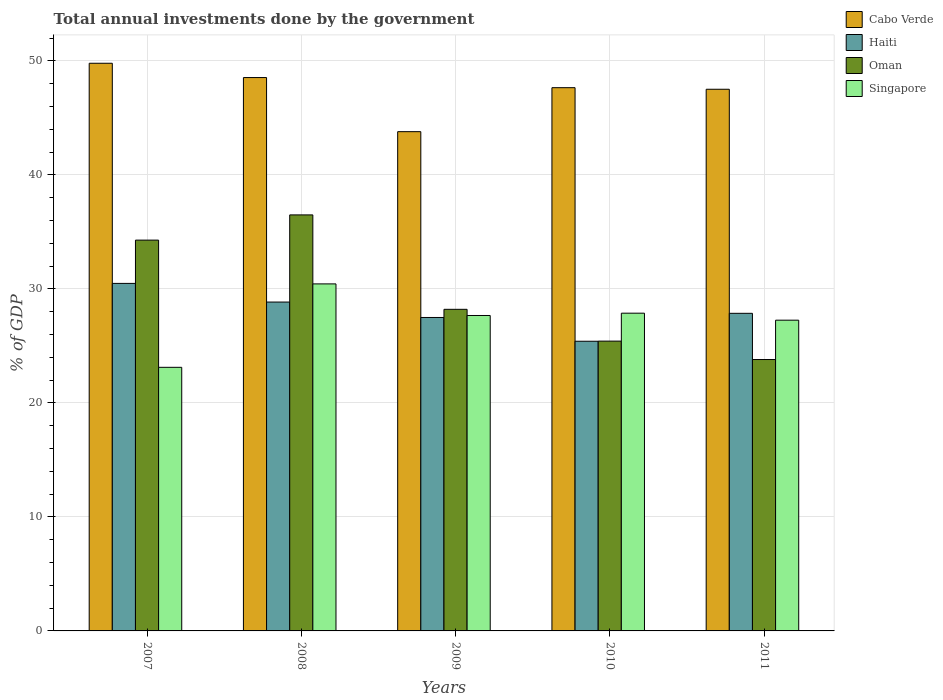How many different coloured bars are there?
Keep it short and to the point. 4. How many groups of bars are there?
Provide a succinct answer. 5. Are the number of bars per tick equal to the number of legend labels?
Keep it short and to the point. Yes. How many bars are there on the 4th tick from the left?
Keep it short and to the point. 4. How many bars are there on the 4th tick from the right?
Offer a terse response. 4. What is the label of the 2nd group of bars from the left?
Your answer should be compact. 2008. What is the total annual investments done by the government in Cabo Verde in 2010?
Your answer should be compact. 47.65. Across all years, what is the maximum total annual investments done by the government in Singapore?
Keep it short and to the point. 30.44. Across all years, what is the minimum total annual investments done by the government in Cabo Verde?
Your response must be concise. 43.79. What is the total total annual investments done by the government in Singapore in the graph?
Keep it short and to the point. 136.35. What is the difference between the total annual investments done by the government in Oman in 2010 and that in 2011?
Offer a terse response. 1.61. What is the difference between the total annual investments done by the government in Singapore in 2011 and the total annual investments done by the government in Cabo Verde in 2009?
Your answer should be compact. -16.53. What is the average total annual investments done by the government in Singapore per year?
Provide a succinct answer. 27.27. In the year 2009, what is the difference between the total annual investments done by the government in Singapore and total annual investments done by the government in Cabo Verde?
Make the answer very short. -16.12. In how many years, is the total annual investments done by the government in Haiti greater than 26 %?
Offer a very short reply. 4. What is the ratio of the total annual investments done by the government in Singapore in 2007 to that in 2008?
Give a very brief answer. 0.76. Is the total annual investments done by the government in Haiti in 2007 less than that in 2009?
Your response must be concise. No. What is the difference between the highest and the second highest total annual investments done by the government in Singapore?
Your answer should be very brief. 2.57. What is the difference between the highest and the lowest total annual investments done by the government in Cabo Verde?
Offer a terse response. 6. Is the sum of the total annual investments done by the government in Haiti in 2008 and 2010 greater than the maximum total annual investments done by the government in Cabo Verde across all years?
Offer a terse response. Yes. Is it the case that in every year, the sum of the total annual investments done by the government in Singapore and total annual investments done by the government in Oman is greater than the sum of total annual investments done by the government in Haiti and total annual investments done by the government in Cabo Verde?
Ensure brevity in your answer.  No. What does the 2nd bar from the left in 2011 represents?
Offer a very short reply. Haiti. What does the 2nd bar from the right in 2008 represents?
Provide a succinct answer. Oman. Is it the case that in every year, the sum of the total annual investments done by the government in Oman and total annual investments done by the government in Singapore is greater than the total annual investments done by the government in Cabo Verde?
Your answer should be very brief. Yes. How many bars are there?
Your answer should be very brief. 20. Are all the bars in the graph horizontal?
Provide a short and direct response. No. How many years are there in the graph?
Provide a short and direct response. 5. Does the graph contain any zero values?
Your answer should be compact. No. Does the graph contain grids?
Make the answer very short. Yes. How many legend labels are there?
Your answer should be very brief. 4. What is the title of the graph?
Offer a very short reply. Total annual investments done by the government. Does "Morocco" appear as one of the legend labels in the graph?
Provide a succinct answer. No. What is the label or title of the Y-axis?
Make the answer very short. % of GDP. What is the % of GDP of Cabo Verde in 2007?
Your response must be concise. 49.79. What is the % of GDP in Haiti in 2007?
Offer a very short reply. 30.48. What is the % of GDP of Oman in 2007?
Keep it short and to the point. 34.28. What is the % of GDP in Singapore in 2007?
Offer a very short reply. 23.12. What is the % of GDP in Cabo Verde in 2008?
Provide a succinct answer. 48.54. What is the % of GDP of Haiti in 2008?
Keep it short and to the point. 28.84. What is the % of GDP in Oman in 2008?
Your answer should be very brief. 36.49. What is the % of GDP in Singapore in 2008?
Make the answer very short. 30.44. What is the % of GDP of Cabo Verde in 2009?
Offer a very short reply. 43.79. What is the % of GDP of Haiti in 2009?
Your answer should be very brief. 27.49. What is the % of GDP of Oman in 2009?
Your response must be concise. 28.21. What is the % of GDP in Singapore in 2009?
Provide a short and direct response. 27.67. What is the % of GDP of Cabo Verde in 2010?
Provide a succinct answer. 47.65. What is the % of GDP in Haiti in 2010?
Give a very brief answer. 25.41. What is the % of GDP in Oman in 2010?
Offer a terse response. 25.42. What is the % of GDP of Singapore in 2010?
Your answer should be compact. 27.87. What is the % of GDP in Cabo Verde in 2011?
Give a very brief answer. 47.51. What is the % of GDP of Haiti in 2011?
Provide a short and direct response. 27.86. What is the % of GDP of Oman in 2011?
Give a very brief answer. 23.8. What is the % of GDP in Singapore in 2011?
Ensure brevity in your answer.  27.26. Across all years, what is the maximum % of GDP of Cabo Verde?
Offer a very short reply. 49.79. Across all years, what is the maximum % of GDP in Haiti?
Offer a very short reply. 30.48. Across all years, what is the maximum % of GDP in Oman?
Provide a succinct answer. 36.49. Across all years, what is the maximum % of GDP in Singapore?
Offer a terse response. 30.44. Across all years, what is the minimum % of GDP of Cabo Verde?
Provide a short and direct response. 43.79. Across all years, what is the minimum % of GDP in Haiti?
Offer a very short reply. 25.41. Across all years, what is the minimum % of GDP of Oman?
Your answer should be compact. 23.8. Across all years, what is the minimum % of GDP of Singapore?
Ensure brevity in your answer.  23.12. What is the total % of GDP in Cabo Verde in the graph?
Give a very brief answer. 237.27. What is the total % of GDP of Haiti in the graph?
Offer a very short reply. 140.08. What is the total % of GDP in Oman in the graph?
Your answer should be very brief. 148.2. What is the total % of GDP in Singapore in the graph?
Offer a terse response. 136.35. What is the difference between the % of GDP in Cabo Verde in 2007 and that in 2008?
Ensure brevity in your answer.  1.25. What is the difference between the % of GDP of Haiti in 2007 and that in 2008?
Offer a terse response. 1.64. What is the difference between the % of GDP in Oman in 2007 and that in 2008?
Provide a succinct answer. -2.21. What is the difference between the % of GDP of Singapore in 2007 and that in 2008?
Provide a short and direct response. -7.32. What is the difference between the % of GDP of Cabo Verde in 2007 and that in 2009?
Keep it short and to the point. 6. What is the difference between the % of GDP of Haiti in 2007 and that in 2009?
Ensure brevity in your answer.  2.99. What is the difference between the % of GDP of Oman in 2007 and that in 2009?
Keep it short and to the point. 6.07. What is the difference between the % of GDP of Singapore in 2007 and that in 2009?
Your response must be concise. -4.55. What is the difference between the % of GDP in Cabo Verde in 2007 and that in 2010?
Offer a very short reply. 2.14. What is the difference between the % of GDP in Haiti in 2007 and that in 2010?
Give a very brief answer. 5.07. What is the difference between the % of GDP in Oman in 2007 and that in 2010?
Give a very brief answer. 8.86. What is the difference between the % of GDP of Singapore in 2007 and that in 2010?
Give a very brief answer. -4.75. What is the difference between the % of GDP in Cabo Verde in 2007 and that in 2011?
Make the answer very short. 2.28. What is the difference between the % of GDP of Haiti in 2007 and that in 2011?
Keep it short and to the point. 2.62. What is the difference between the % of GDP of Oman in 2007 and that in 2011?
Give a very brief answer. 10.47. What is the difference between the % of GDP of Singapore in 2007 and that in 2011?
Your answer should be compact. -4.13. What is the difference between the % of GDP in Cabo Verde in 2008 and that in 2009?
Keep it short and to the point. 4.75. What is the difference between the % of GDP in Haiti in 2008 and that in 2009?
Your answer should be very brief. 1.35. What is the difference between the % of GDP in Oman in 2008 and that in 2009?
Give a very brief answer. 8.28. What is the difference between the % of GDP in Singapore in 2008 and that in 2009?
Provide a short and direct response. 2.77. What is the difference between the % of GDP of Cabo Verde in 2008 and that in 2010?
Give a very brief answer. 0.89. What is the difference between the % of GDP in Haiti in 2008 and that in 2010?
Your response must be concise. 3.44. What is the difference between the % of GDP of Oman in 2008 and that in 2010?
Provide a short and direct response. 11.07. What is the difference between the % of GDP in Singapore in 2008 and that in 2010?
Keep it short and to the point. 2.57. What is the difference between the % of GDP of Cabo Verde in 2008 and that in 2011?
Your response must be concise. 1.03. What is the difference between the % of GDP of Haiti in 2008 and that in 2011?
Provide a succinct answer. 0.99. What is the difference between the % of GDP of Oman in 2008 and that in 2011?
Provide a succinct answer. 12.68. What is the difference between the % of GDP of Singapore in 2008 and that in 2011?
Offer a terse response. 3.18. What is the difference between the % of GDP in Cabo Verde in 2009 and that in 2010?
Offer a very short reply. -3.86. What is the difference between the % of GDP in Haiti in 2009 and that in 2010?
Your answer should be compact. 2.09. What is the difference between the % of GDP in Oman in 2009 and that in 2010?
Offer a terse response. 2.79. What is the difference between the % of GDP of Singapore in 2009 and that in 2010?
Your answer should be very brief. -0.2. What is the difference between the % of GDP of Cabo Verde in 2009 and that in 2011?
Offer a terse response. -3.72. What is the difference between the % of GDP in Haiti in 2009 and that in 2011?
Your answer should be compact. -0.36. What is the difference between the % of GDP in Oman in 2009 and that in 2011?
Offer a very short reply. 4.4. What is the difference between the % of GDP of Singapore in 2009 and that in 2011?
Your answer should be very brief. 0.41. What is the difference between the % of GDP of Cabo Verde in 2010 and that in 2011?
Offer a terse response. 0.14. What is the difference between the % of GDP in Haiti in 2010 and that in 2011?
Provide a succinct answer. -2.45. What is the difference between the % of GDP in Oman in 2010 and that in 2011?
Offer a terse response. 1.61. What is the difference between the % of GDP in Singapore in 2010 and that in 2011?
Your response must be concise. 0.61. What is the difference between the % of GDP in Cabo Verde in 2007 and the % of GDP in Haiti in 2008?
Keep it short and to the point. 20.95. What is the difference between the % of GDP in Cabo Verde in 2007 and the % of GDP in Oman in 2008?
Your response must be concise. 13.3. What is the difference between the % of GDP of Cabo Verde in 2007 and the % of GDP of Singapore in 2008?
Ensure brevity in your answer.  19.35. What is the difference between the % of GDP in Haiti in 2007 and the % of GDP in Oman in 2008?
Make the answer very short. -6.01. What is the difference between the % of GDP in Haiti in 2007 and the % of GDP in Singapore in 2008?
Keep it short and to the point. 0.04. What is the difference between the % of GDP in Oman in 2007 and the % of GDP in Singapore in 2008?
Keep it short and to the point. 3.84. What is the difference between the % of GDP of Cabo Verde in 2007 and the % of GDP of Haiti in 2009?
Your response must be concise. 22.3. What is the difference between the % of GDP in Cabo Verde in 2007 and the % of GDP in Oman in 2009?
Provide a succinct answer. 21.58. What is the difference between the % of GDP of Cabo Verde in 2007 and the % of GDP of Singapore in 2009?
Your answer should be very brief. 22.12. What is the difference between the % of GDP of Haiti in 2007 and the % of GDP of Oman in 2009?
Keep it short and to the point. 2.27. What is the difference between the % of GDP of Haiti in 2007 and the % of GDP of Singapore in 2009?
Your answer should be very brief. 2.82. What is the difference between the % of GDP of Oman in 2007 and the % of GDP of Singapore in 2009?
Your answer should be very brief. 6.61. What is the difference between the % of GDP of Cabo Verde in 2007 and the % of GDP of Haiti in 2010?
Your answer should be very brief. 24.38. What is the difference between the % of GDP in Cabo Verde in 2007 and the % of GDP in Oman in 2010?
Your response must be concise. 24.37. What is the difference between the % of GDP of Cabo Verde in 2007 and the % of GDP of Singapore in 2010?
Your answer should be compact. 21.92. What is the difference between the % of GDP in Haiti in 2007 and the % of GDP in Oman in 2010?
Your answer should be very brief. 5.06. What is the difference between the % of GDP of Haiti in 2007 and the % of GDP of Singapore in 2010?
Provide a short and direct response. 2.61. What is the difference between the % of GDP of Oman in 2007 and the % of GDP of Singapore in 2010?
Provide a succinct answer. 6.41. What is the difference between the % of GDP of Cabo Verde in 2007 and the % of GDP of Haiti in 2011?
Offer a very short reply. 21.93. What is the difference between the % of GDP of Cabo Verde in 2007 and the % of GDP of Oman in 2011?
Provide a succinct answer. 25.98. What is the difference between the % of GDP in Cabo Verde in 2007 and the % of GDP in Singapore in 2011?
Your answer should be very brief. 22.53. What is the difference between the % of GDP in Haiti in 2007 and the % of GDP in Oman in 2011?
Your answer should be very brief. 6.68. What is the difference between the % of GDP in Haiti in 2007 and the % of GDP in Singapore in 2011?
Provide a short and direct response. 3.23. What is the difference between the % of GDP of Oman in 2007 and the % of GDP of Singapore in 2011?
Offer a very short reply. 7.02. What is the difference between the % of GDP in Cabo Verde in 2008 and the % of GDP in Haiti in 2009?
Give a very brief answer. 21.04. What is the difference between the % of GDP of Cabo Verde in 2008 and the % of GDP of Oman in 2009?
Offer a very short reply. 20.33. What is the difference between the % of GDP of Cabo Verde in 2008 and the % of GDP of Singapore in 2009?
Offer a terse response. 20.87. What is the difference between the % of GDP of Haiti in 2008 and the % of GDP of Oman in 2009?
Make the answer very short. 0.64. What is the difference between the % of GDP in Haiti in 2008 and the % of GDP in Singapore in 2009?
Ensure brevity in your answer.  1.18. What is the difference between the % of GDP of Oman in 2008 and the % of GDP of Singapore in 2009?
Make the answer very short. 8.82. What is the difference between the % of GDP in Cabo Verde in 2008 and the % of GDP in Haiti in 2010?
Provide a short and direct response. 23.13. What is the difference between the % of GDP of Cabo Verde in 2008 and the % of GDP of Oman in 2010?
Offer a very short reply. 23.12. What is the difference between the % of GDP in Cabo Verde in 2008 and the % of GDP in Singapore in 2010?
Your response must be concise. 20.67. What is the difference between the % of GDP of Haiti in 2008 and the % of GDP of Oman in 2010?
Provide a succinct answer. 3.43. What is the difference between the % of GDP in Haiti in 2008 and the % of GDP in Singapore in 2010?
Offer a terse response. 0.97. What is the difference between the % of GDP of Oman in 2008 and the % of GDP of Singapore in 2010?
Provide a succinct answer. 8.62. What is the difference between the % of GDP in Cabo Verde in 2008 and the % of GDP in Haiti in 2011?
Keep it short and to the point. 20.68. What is the difference between the % of GDP of Cabo Verde in 2008 and the % of GDP of Oman in 2011?
Offer a terse response. 24.73. What is the difference between the % of GDP in Cabo Verde in 2008 and the % of GDP in Singapore in 2011?
Keep it short and to the point. 21.28. What is the difference between the % of GDP in Haiti in 2008 and the % of GDP in Oman in 2011?
Make the answer very short. 5.04. What is the difference between the % of GDP of Haiti in 2008 and the % of GDP of Singapore in 2011?
Keep it short and to the point. 1.59. What is the difference between the % of GDP in Oman in 2008 and the % of GDP in Singapore in 2011?
Your response must be concise. 9.23. What is the difference between the % of GDP in Cabo Verde in 2009 and the % of GDP in Haiti in 2010?
Make the answer very short. 18.38. What is the difference between the % of GDP of Cabo Verde in 2009 and the % of GDP of Oman in 2010?
Keep it short and to the point. 18.37. What is the difference between the % of GDP of Cabo Verde in 2009 and the % of GDP of Singapore in 2010?
Provide a succinct answer. 15.92. What is the difference between the % of GDP in Haiti in 2009 and the % of GDP in Oman in 2010?
Make the answer very short. 2.07. What is the difference between the % of GDP in Haiti in 2009 and the % of GDP in Singapore in 2010?
Your answer should be very brief. -0.38. What is the difference between the % of GDP of Oman in 2009 and the % of GDP of Singapore in 2010?
Your response must be concise. 0.34. What is the difference between the % of GDP of Cabo Verde in 2009 and the % of GDP of Haiti in 2011?
Your answer should be very brief. 15.93. What is the difference between the % of GDP in Cabo Verde in 2009 and the % of GDP in Oman in 2011?
Provide a succinct answer. 19.98. What is the difference between the % of GDP in Cabo Verde in 2009 and the % of GDP in Singapore in 2011?
Your answer should be very brief. 16.53. What is the difference between the % of GDP of Haiti in 2009 and the % of GDP of Oman in 2011?
Offer a terse response. 3.69. What is the difference between the % of GDP of Haiti in 2009 and the % of GDP of Singapore in 2011?
Provide a succinct answer. 0.24. What is the difference between the % of GDP of Oman in 2009 and the % of GDP of Singapore in 2011?
Make the answer very short. 0.95. What is the difference between the % of GDP in Cabo Verde in 2010 and the % of GDP in Haiti in 2011?
Your response must be concise. 19.79. What is the difference between the % of GDP of Cabo Verde in 2010 and the % of GDP of Oman in 2011?
Your answer should be very brief. 23.84. What is the difference between the % of GDP in Cabo Verde in 2010 and the % of GDP in Singapore in 2011?
Offer a very short reply. 20.39. What is the difference between the % of GDP in Haiti in 2010 and the % of GDP in Oman in 2011?
Provide a succinct answer. 1.6. What is the difference between the % of GDP of Haiti in 2010 and the % of GDP of Singapore in 2011?
Provide a short and direct response. -1.85. What is the difference between the % of GDP in Oman in 2010 and the % of GDP in Singapore in 2011?
Keep it short and to the point. -1.84. What is the average % of GDP of Cabo Verde per year?
Provide a short and direct response. 47.45. What is the average % of GDP in Haiti per year?
Provide a succinct answer. 28.02. What is the average % of GDP in Oman per year?
Offer a very short reply. 29.64. What is the average % of GDP in Singapore per year?
Your response must be concise. 27.27. In the year 2007, what is the difference between the % of GDP in Cabo Verde and % of GDP in Haiti?
Keep it short and to the point. 19.31. In the year 2007, what is the difference between the % of GDP in Cabo Verde and % of GDP in Oman?
Offer a terse response. 15.51. In the year 2007, what is the difference between the % of GDP in Cabo Verde and % of GDP in Singapore?
Offer a very short reply. 26.67. In the year 2007, what is the difference between the % of GDP of Haiti and % of GDP of Oman?
Offer a terse response. -3.8. In the year 2007, what is the difference between the % of GDP in Haiti and % of GDP in Singapore?
Ensure brevity in your answer.  7.36. In the year 2007, what is the difference between the % of GDP of Oman and % of GDP of Singapore?
Your answer should be very brief. 11.16. In the year 2008, what is the difference between the % of GDP of Cabo Verde and % of GDP of Haiti?
Make the answer very short. 19.69. In the year 2008, what is the difference between the % of GDP of Cabo Verde and % of GDP of Oman?
Make the answer very short. 12.05. In the year 2008, what is the difference between the % of GDP in Cabo Verde and % of GDP in Singapore?
Give a very brief answer. 18.1. In the year 2008, what is the difference between the % of GDP in Haiti and % of GDP in Oman?
Offer a terse response. -7.64. In the year 2008, what is the difference between the % of GDP of Haiti and % of GDP of Singapore?
Offer a very short reply. -1.59. In the year 2008, what is the difference between the % of GDP of Oman and % of GDP of Singapore?
Provide a succinct answer. 6.05. In the year 2009, what is the difference between the % of GDP in Cabo Verde and % of GDP in Haiti?
Make the answer very short. 16.3. In the year 2009, what is the difference between the % of GDP in Cabo Verde and % of GDP in Oman?
Your answer should be very brief. 15.58. In the year 2009, what is the difference between the % of GDP of Cabo Verde and % of GDP of Singapore?
Keep it short and to the point. 16.12. In the year 2009, what is the difference between the % of GDP of Haiti and % of GDP of Oman?
Ensure brevity in your answer.  -0.71. In the year 2009, what is the difference between the % of GDP in Haiti and % of GDP in Singapore?
Make the answer very short. -0.17. In the year 2009, what is the difference between the % of GDP of Oman and % of GDP of Singapore?
Ensure brevity in your answer.  0.54. In the year 2010, what is the difference between the % of GDP in Cabo Verde and % of GDP in Haiti?
Provide a succinct answer. 22.24. In the year 2010, what is the difference between the % of GDP in Cabo Verde and % of GDP in Oman?
Your answer should be very brief. 22.23. In the year 2010, what is the difference between the % of GDP of Cabo Verde and % of GDP of Singapore?
Ensure brevity in your answer.  19.78. In the year 2010, what is the difference between the % of GDP in Haiti and % of GDP in Oman?
Provide a short and direct response. -0.01. In the year 2010, what is the difference between the % of GDP of Haiti and % of GDP of Singapore?
Ensure brevity in your answer.  -2.46. In the year 2010, what is the difference between the % of GDP of Oman and % of GDP of Singapore?
Your response must be concise. -2.45. In the year 2011, what is the difference between the % of GDP of Cabo Verde and % of GDP of Haiti?
Provide a succinct answer. 19.65. In the year 2011, what is the difference between the % of GDP in Cabo Verde and % of GDP in Oman?
Ensure brevity in your answer.  23.7. In the year 2011, what is the difference between the % of GDP in Cabo Verde and % of GDP in Singapore?
Your answer should be very brief. 20.25. In the year 2011, what is the difference between the % of GDP of Haiti and % of GDP of Oman?
Offer a terse response. 4.05. In the year 2011, what is the difference between the % of GDP in Haiti and % of GDP in Singapore?
Your response must be concise. 0.6. In the year 2011, what is the difference between the % of GDP of Oman and % of GDP of Singapore?
Keep it short and to the point. -3.45. What is the ratio of the % of GDP in Cabo Verde in 2007 to that in 2008?
Your response must be concise. 1.03. What is the ratio of the % of GDP of Haiti in 2007 to that in 2008?
Make the answer very short. 1.06. What is the ratio of the % of GDP of Oman in 2007 to that in 2008?
Your answer should be compact. 0.94. What is the ratio of the % of GDP of Singapore in 2007 to that in 2008?
Provide a short and direct response. 0.76. What is the ratio of the % of GDP in Cabo Verde in 2007 to that in 2009?
Provide a succinct answer. 1.14. What is the ratio of the % of GDP in Haiti in 2007 to that in 2009?
Keep it short and to the point. 1.11. What is the ratio of the % of GDP in Oman in 2007 to that in 2009?
Your response must be concise. 1.22. What is the ratio of the % of GDP in Singapore in 2007 to that in 2009?
Keep it short and to the point. 0.84. What is the ratio of the % of GDP in Cabo Verde in 2007 to that in 2010?
Your response must be concise. 1.04. What is the ratio of the % of GDP in Haiti in 2007 to that in 2010?
Provide a short and direct response. 1.2. What is the ratio of the % of GDP in Oman in 2007 to that in 2010?
Provide a short and direct response. 1.35. What is the ratio of the % of GDP in Singapore in 2007 to that in 2010?
Give a very brief answer. 0.83. What is the ratio of the % of GDP of Cabo Verde in 2007 to that in 2011?
Provide a succinct answer. 1.05. What is the ratio of the % of GDP of Haiti in 2007 to that in 2011?
Offer a terse response. 1.09. What is the ratio of the % of GDP of Oman in 2007 to that in 2011?
Provide a succinct answer. 1.44. What is the ratio of the % of GDP of Singapore in 2007 to that in 2011?
Provide a short and direct response. 0.85. What is the ratio of the % of GDP in Cabo Verde in 2008 to that in 2009?
Keep it short and to the point. 1.11. What is the ratio of the % of GDP in Haiti in 2008 to that in 2009?
Provide a short and direct response. 1.05. What is the ratio of the % of GDP in Oman in 2008 to that in 2009?
Your response must be concise. 1.29. What is the ratio of the % of GDP in Singapore in 2008 to that in 2009?
Offer a very short reply. 1.1. What is the ratio of the % of GDP in Cabo Verde in 2008 to that in 2010?
Your answer should be very brief. 1.02. What is the ratio of the % of GDP in Haiti in 2008 to that in 2010?
Give a very brief answer. 1.14. What is the ratio of the % of GDP of Oman in 2008 to that in 2010?
Offer a terse response. 1.44. What is the ratio of the % of GDP of Singapore in 2008 to that in 2010?
Keep it short and to the point. 1.09. What is the ratio of the % of GDP of Cabo Verde in 2008 to that in 2011?
Provide a short and direct response. 1.02. What is the ratio of the % of GDP in Haiti in 2008 to that in 2011?
Your answer should be compact. 1.04. What is the ratio of the % of GDP in Oman in 2008 to that in 2011?
Your answer should be very brief. 1.53. What is the ratio of the % of GDP in Singapore in 2008 to that in 2011?
Provide a succinct answer. 1.12. What is the ratio of the % of GDP of Cabo Verde in 2009 to that in 2010?
Keep it short and to the point. 0.92. What is the ratio of the % of GDP in Haiti in 2009 to that in 2010?
Provide a short and direct response. 1.08. What is the ratio of the % of GDP in Oman in 2009 to that in 2010?
Your answer should be compact. 1.11. What is the ratio of the % of GDP in Cabo Verde in 2009 to that in 2011?
Your answer should be very brief. 0.92. What is the ratio of the % of GDP of Haiti in 2009 to that in 2011?
Give a very brief answer. 0.99. What is the ratio of the % of GDP of Oman in 2009 to that in 2011?
Give a very brief answer. 1.19. What is the ratio of the % of GDP in Singapore in 2009 to that in 2011?
Your answer should be compact. 1.02. What is the ratio of the % of GDP of Haiti in 2010 to that in 2011?
Ensure brevity in your answer.  0.91. What is the ratio of the % of GDP of Oman in 2010 to that in 2011?
Your answer should be very brief. 1.07. What is the ratio of the % of GDP in Singapore in 2010 to that in 2011?
Ensure brevity in your answer.  1.02. What is the difference between the highest and the second highest % of GDP in Cabo Verde?
Offer a very short reply. 1.25. What is the difference between the highest and the second highest % of GDP of Haiti?
Your answer should be very brief. 1.64. What is the difference between the highest and the second highest % of GDP in Oman?
Your answer should be compact. 2.21. What is the difference between the highest and the second highest % of GDP in Singapore?
Your answer should be compact. 2.57. What is the difference between the highest and the lowest % of GDP of Cabo Verde?
Your response must be concise. 6. What is the difference between the highest and the lowest % of GDP in Haiti?
Ensure brevity in your answer.  5.07. What is the difference between the highest and the lowest % of GDP of Oman?
Provide a short and direct response. 12.68. What is the difference between the highest and the lowest % of GDP of Singapore?
Provide a succinct answer. 7.32. 